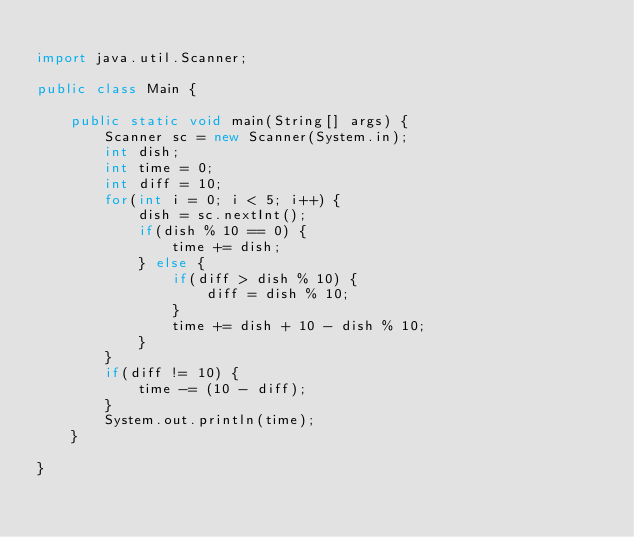<code> <loc_0><loc_0><loc_500><loc_500><_Java_>
import java.util.Scanner;

public class Main {

	public static void main(String[] args) {
		Scanner sc = new Scanner(System.in);
		int dish;
		int time = 0;
		int diff = 10;
		for(int i = 0; i < 5; i++) {
			dish = sc.nextInt();
			if(dish % 10 == 0) {
				time += dish;
			} else {
				if(diff > dish % 10) {
					diff = dish % 10;
				}
				time += dish + 10 - dish % 10;
			}
		}
		if(diff != 10) {
			time -= (10 - diff);
		}
		System.out.println(time);
	}

}
</code> 